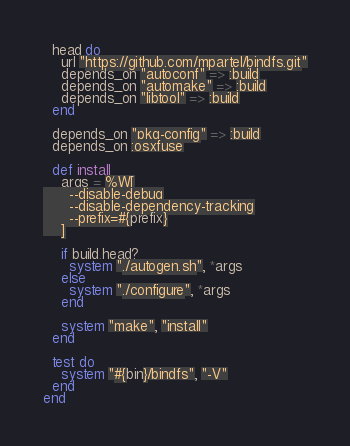Convert code to text. <code><loc_0><loc_0><loc_500><loc_500><_Ruby_>  head do
    url "https://github.com/mpartel/bindfs.git"
    depends_on "autoconf" => :build
    depends_on "automake" => :build
    depends_on "libtool" => :build
  end

  depends_on "pkg-config" => :build
  depends_on :osxfuse

  def install
    args = %W[
      --disable-debug
      --disable-dependency-tracking
      --prefix=#{prefix}
    ]

    if build.head?
      system "./autogen.sh", *args
    else
      system "./configure", *args
    end

    system "make", "install"
  end

  test do
    system "#{bin}/bindfs", "-V"
  end
end
</code> 